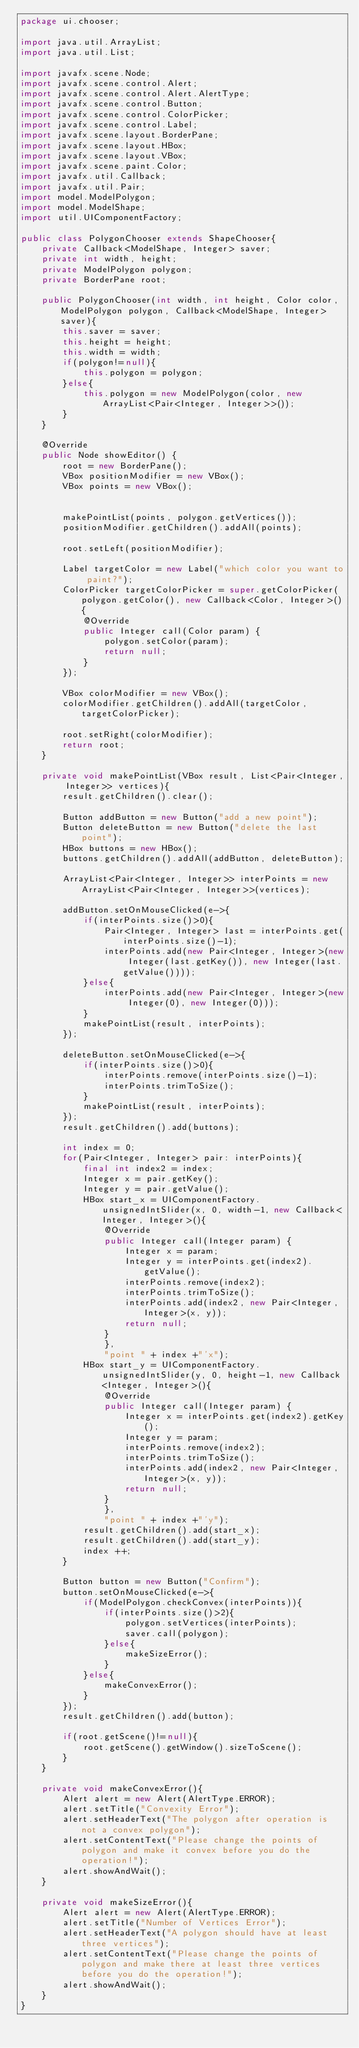Convert code to text. <code><loc_0><loc_0><loc_500><loc_500><_Java_>package ui.chooser;

import java.util.ArrayList;
import java.util.List;

import javafx.scene.Node;
import javafx.scene.control.Alert;
import javafx.scene.control.Alert.AlertType;
import javafx.scene.control.Button;
import javafx.scene.control.ColorPicker;
import javafx.scene.control.Label;
import javafx.scene.layout.BorderPane;
import javafx.scene.layout.HBox;
import javafx.scene.layout.VBox;
import javafx.scene.paint.Color;
import javafx.util.Callback;
import javafx.util.Pair;
import model.ModelPolygon;
import model.ModelShape;
import util.UIComponentFactory;

public class PolygonChooser extends ShapeChooser{
	private Callback<ModelShape, Integer> saver;
	private int width, height;
	private ModelPolygon polygon;
	private BorderPane root;

	public PolygonChooser(int width, int height, Color color, ModelPolygon polygon, Callback<ModelShape, Integer> saver){
		this.saver = saver;
		this.height = height;
		this.width = width;
		if(polygon!=null){
			this.polygon = polygon;
		}else{
			this.polygon = new ModelPolygon(color, new ArrayList<Pair<Integer, Integer>>());
		}
	}
	
	@Override
	public Node showEditor() {
		root = new BorderPane();
		VBox positionModifier = new VBox();
		VBox points = new VBox();
		
		
		makePointList(points, polygon.getVertices());
		positionModifier.getChildren().addAll(points);
		
		root.setLeft(positionModifier);
		
		Label targetColor = new Label("which color you want to paint?");
		ColorPicker targetColorPicker = super.getColorPicker(polygon.getColor(), new Callback<Color, Integer>(){
			@Override
			public Integer call(Color param) {
				polygon.setColor(param);
				return null;
			}
		});
		
		VBox colorModifier = new VBox();
		colorModifier.getChildren().addAll(targetColor, targetColorPicker);
		
		root.setRight(colorModifier);
		return root;
	}
	
	private void makePointList(VBox result, List<Pair<Integer, Integer>> vertices){
		result.getChildren().clear();
		
		Button addButton = new Button("add a new point");
		Button deleteButton = new Button("delete the last point");
		HBox buttons = new HBox();
		buttons.getChildren().addAll(addButton, deleteButton);
		
		ArrayList<Pair<Integer, Integer>> interPoints = new ArrayList<Pair<Integer, Integer>>(vertices);
		
		addButton.setOnMouseClicked(e->{
			if(interPoints.size()>0){
				Pair<Integer, Integer> last = interPoints.get(interPoints.size()-1);
				interPoints.add(new Pair<Integer, Integer>(new Integer(last.getKey()), new Integer(last.getValue())));
			}else{
				interPoints.add(new Pair<Integer, Integer>(new Integer(0), new Integer(0)));
			}
			makePointList(result, interPoints);
		});
		
		deleteButton.setOnMouseClicked(e->{
			if(interPoints.size()>0){
				interPoints.remove(interPoints.size()-1);
				interPoints.trimToSize();
			}
			makePointList(result, interPoints);
		});
		result.getChildren().add(buttons);

		int index = 0;
		for(Pair<Integer, Integer> pair: interPoints){
			final int index2 = index;
			Integer x = pair.getKey();
			Integer y = pair.getValue();
			HBox start_x = UIComponentFactory.unsignedIntSlider(x, 0, width-1, new Callback<Integer, Integer>(){
				@Override
				public Integer call(Integer param) {
					Integer x = param;
					Integer y = interPoints.get(index2).getValue();
					interPoints.remove(index2);
					interPoints.trimToSize();
					interPoints.add(index2, new Pair<Integer, Integer>(x, y));
					return null;
				}
				}, 
				"point " + index +"'x");
			HBox start_y = UIComponentFactory.unsignedIntSlider(y, 0, height-1, new Callback<Integer, Integer>(){
				@Override
				public Integer call(Integer param) {
					Integer x = interPoints.get(index2).getKey();
					Integer y = param;
					interPoints.remove(index2);
					interPoints.trimToSize();
					interPoints.add(index2, new Pair<Integer, Integer>(x, y));
					return null;
				}
				}, 
				"point " + index +"'y");
			result.getChildren().add(start_x);
			result.getChildren().add(start_y);
			index ++;
		}
		
		Button button = new Button("Confirm");
		button.setOnMouseClicked(e->{
			if(ModelPolygon.checkConvex(interPoints)){
				if(interPoints.size()>2){
					polygon.setVertices(interPoints);
					saver.call(polygon);
				}else{
					makeSizeError();
				}
			}else{
				makeConvexError();
			}
		});
		result.getChildren().add(button);
		
		if(root.getScene()!=null){
			root.getScene().getWindow().sizeToScene();
		}
	}
	
	private void makeConvexError(){
		Alert alert = new Alert(AlertType.ERROR);
		alert.setTitle("Convexity Error");
		alert.setHeaderText("The polygon after operation is not a convex polygon");
		alert.setContentText("Please change the points of polygon and make it convex before you do the operation!");
		alert.showAndWait();
	}
	
	private void makeSizeError(){
		Alert alert = new Alert(AlertType.ERROR);
		alert.setTitle("Number of Vertices Error");
		alert.setHeaderText("A polygon should have at least three vertices");
		alert.setContentText("Please change the points of polygon and make there at least three vertices before you do the operation!");
		alert.showAndWait();
	}
}
</code> 